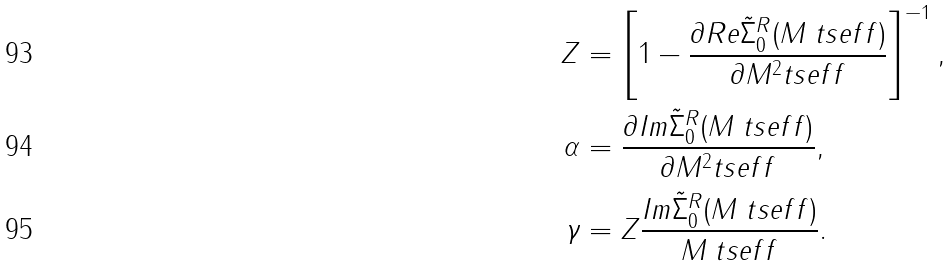<formula> <loc_0><loc_0><loc_500><loc_500>Z & = \left [ 1 - \frac { \partial R e \tilde { \Sigma } ^ { R } _ { 0 } ( M _ { \ } t s { e f f } ) } { \partial M ^ { 2 } _ { \ } t s { e f f } } \right ] ^ { - 1 } , \\ \alpha & = \frac { \partial I m \tilde { \Sigma } ^ { R } _ { 0 } ( M _ { \ } t s { e f f } ) } { \partial M ^ { 2 } _ { \ } t s { e f f } } , \\ \gamma & = Z \frac { I m \tilde { \Sigma } ^ { R } _ { 0 } ( M _ { \ } t s { e f f } ) } { M _ { \ } t s { e f f } } .</formula> 